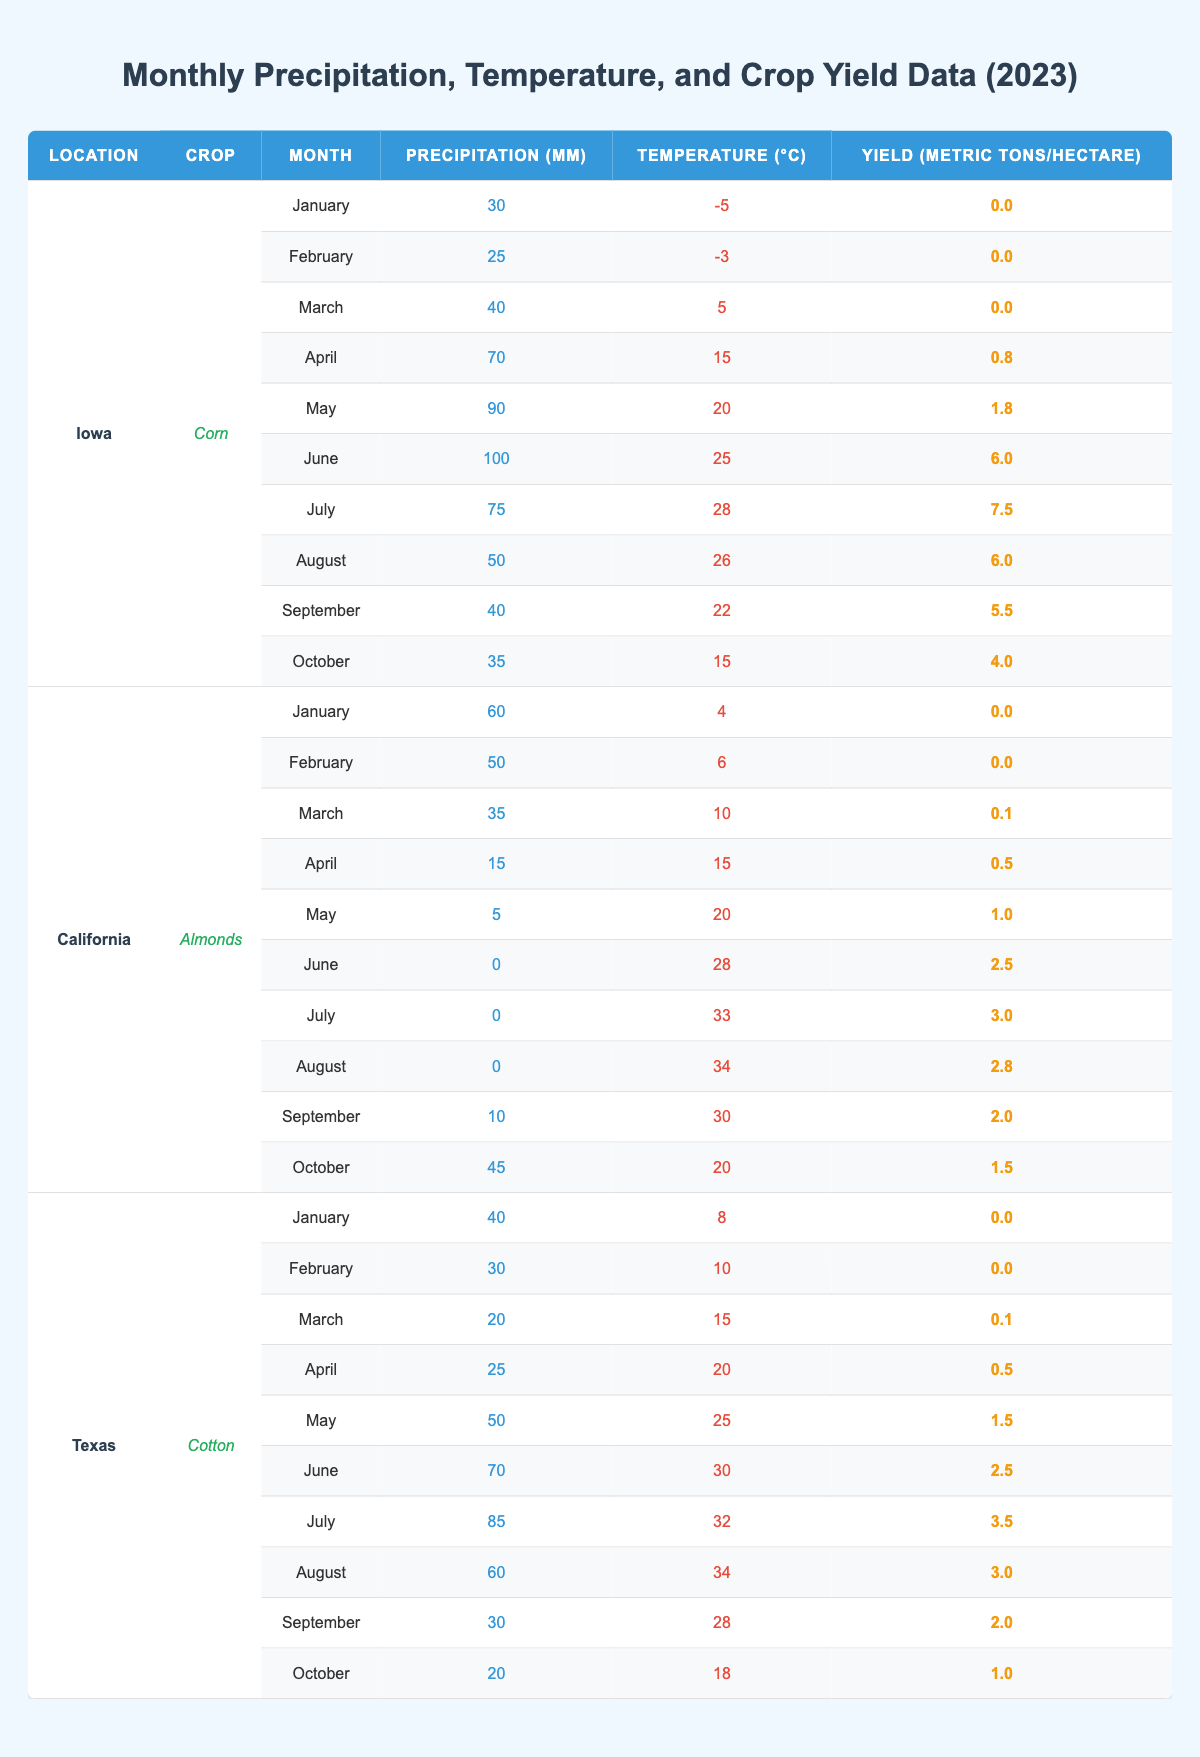What is the crop yield for Corn in Iowa during July? The table shows that in July, the yield for Corn in Iowa is 7.5 metric tons per hectare.
Answer: 7.5 What is the total precipitation for the month of August in California for Almonds? The table indicates that in August, the precipitation for Almonds in California is 0 mm.
Answer: 0 What was the average temperature in Texas from January to March for Cotton? The temperatures for January, February, and March are 8°C, 10°C, and 15°C respectively. The average is (8 + 10 + 15) / 3 = 11°C.
Answer: 11 Is the yield for Almonds in California higher in July compared to June? In July, the yield is 3.0 metric tons per hectare, and in June, it is 2.5 metric tons per hectare. Since 3.0 > 2.5, the yield in July is indeed higher.
Answer: Yes What is the highest yield for Corn in Iowa, and in which month does it occur? Scanning the table, the highest yield for Corn in Iowa is 7.5 metric tons per hectare in July.
Answer: 7.5 in July What is the difference in yield for Cotton between June and August in Texas? For Cotton in Texas, the yield in June is 2.5 metric tons per hectare and in August is 3.0 metric tons per hectare. The difference is 3.0 - 2.5 = 0.5.
Answer: 0.5 What was the total precipitation for Corn in Iowa from April to October? The precipitation amounts from April to October are 70, 90, 100, 75, 50, 40, and 35 mm respectively. The total is 70 + 90 + 100 + 75 + 50 + 40 + 35 = 460 mm.
Answer: 460 Was there any month in which Almonds in California had a yield of zero? Checking the table, the months of January and February both show a yield of 0 metric tons per hectare. Therefore, yes, there were months with zero yield.
Answer: Yes What is the average precipitation for Corn in Iowa from May to August? The precipitation values for May, June, July, and August are 90, 100, 75, and 50 mm respectively. The average is (90 + 100 + 75 + 50) / 4 = 79.375 mm.
Answer: 79.375 In which month did Cotton in Texas experience the highest temperature, and what was that temperature? The temperatures for Cotton in Texas peak at 34°C in August.
Answer: August, 34°C What is the minimum yield for Almonds in California, and when does it occur? The table shows the minimum yield of 0.0 metric tons per hectare occurring in January and February.
Answer: 0.0 in January and February 